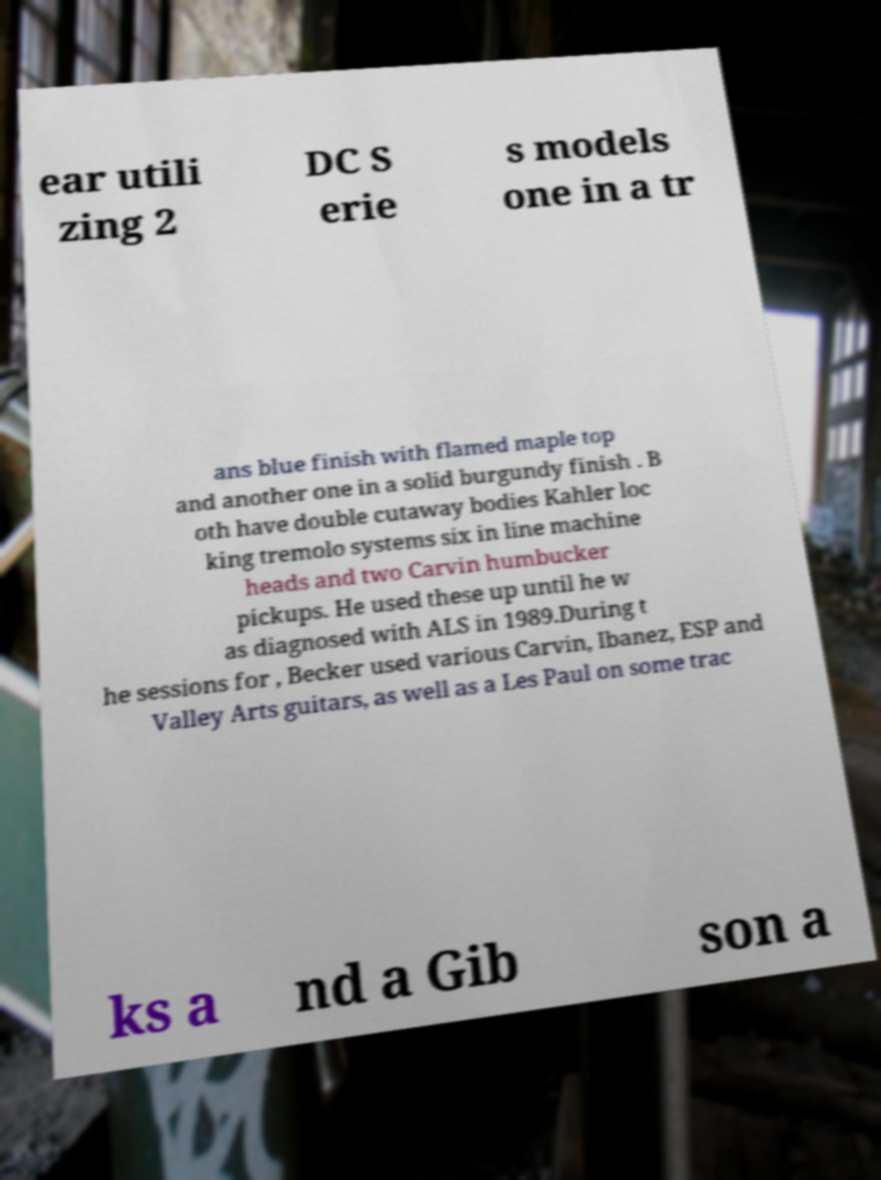Could you assist in decoding the text presented in this image and type it out clearly? ear utili zing 2 DC S erie s models one in a tr ans blue finish with flamed maple top and another one in a solid burgundy finish . B oth have double cutaway bodies Kahler loc king tremolo systems six in line machine heads and two Carvin humbucker pickups. He used these up until he w as diagnosed with ALS in 1989.During t he sessions for , Becker used various Carvin, Ibanez, ESP and Valley Arts guitars, as well as a Les Paul on some trac ks a nd a Gib son a 